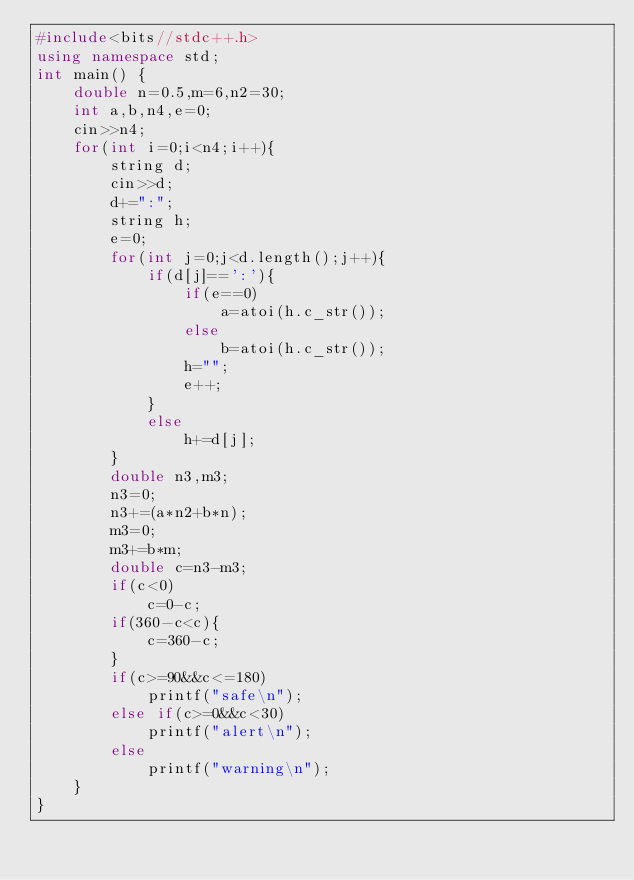<code> <loc_0><loc_0><loc_500><loc_500><_C++_>#include<bits//stdc++.h>
using namespace std;
int main() {
	double n=0.5,m=6,n2=30;
	int a,b,n4,e=0;
	cin>>n4;
	for(int i=0;i<n4;i++){
		string d;
		cin>>d;
		d+=":";
		string h;
		e=0;
		for(int j=0;j<d.length();j++){
			if(d[j]==':'){
				if(e==0)
					a=atoi(h.c_str());
				else
					b=atoi(h.c_str());
				h="";
				e++;
			}
			else
				h+=d[j];
		}
		double n3,m3;
		n3=0;
		n3+=(a*n2+b*n);
		m3=0;
		m3+=b*m;
		double c=n3-m3;
		if(c<0)
			c=0-c;
		if(360-c<c){
			c=360-c;
		}
		if(c>=90&&c<=180)
			printf("safe\n");
		else if(c>=0&&c<30)
			printf("alert\n");
		else
			printf("warning\n");
	}
}</code> 